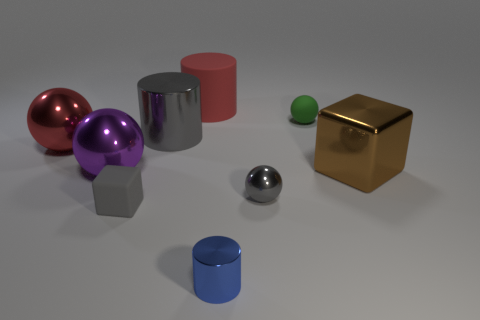There is a gray shiny sphere; are there any large red metal objects in front of it?
Make the answer very short. No. There is a tiny thing that is behind the small gray rubber object and to the left of the green matte object; what material is it?
Keep it short and to the point. Metal. What is the color of the tiny shiny object that is the same shape as the big purple metal thing?
Keep it short and to the point. Gray. Is there a green object that is in front of the gray thing that is right of the small cylinder?
Provide a short and direct response. No. The red sphere has what size?
Give a very brief answer. Large. What shape is the matte object that is both on the left side of the blue object and in front of the large red matte object?
Offer a terse response. Cube. How many red things are matte cylinders or matte blocks?
Make the answer very short. 1. There is a object to the right of the green thing; does it have the same size as the metal ball to the right of the big rubber thing?
Your response must be concise. No. What number of objects are either small brown shiny balls or red matte cylinders?
Keep it short and to the point. 1. Are there any gray shiny objects that have the same shape as the blue metal thing?
Keep it short and to the point. Yes. 